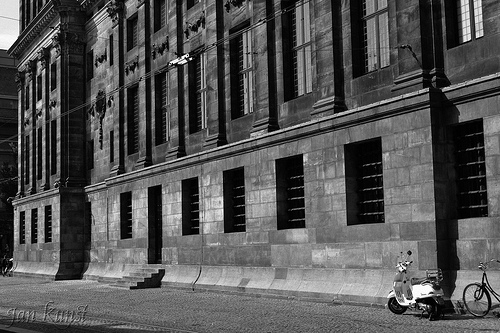Imagine the scene in a different season. How would it look during winter? During winter, the scene would transform dramatically. Snow would likely cover the sidewalk and building, adding a layer of purity and coldness. The windows would have frosted edges, and the bicycle and scooter might be covered with a thin layer of snow, adding to the stillness and serenity of the scene. The historic building in the backdrop would look even more majestic adorned in winter's blanket. 